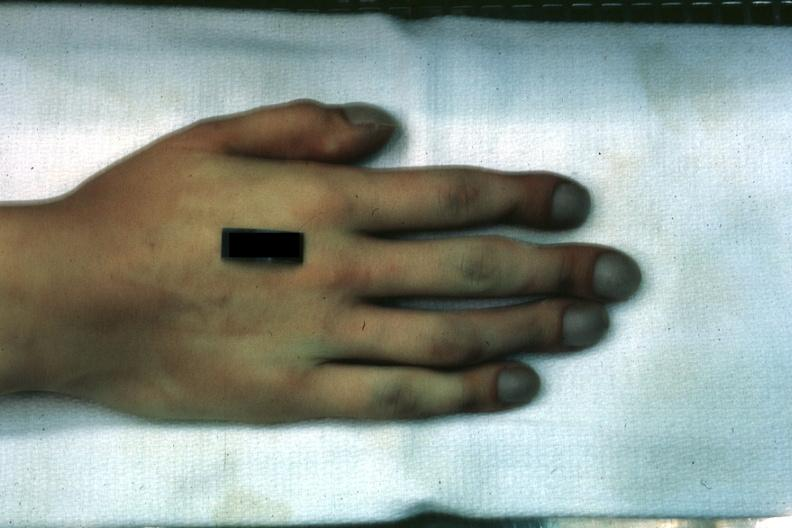what are present?
Answer the question using a single word or phrase. Extremities 